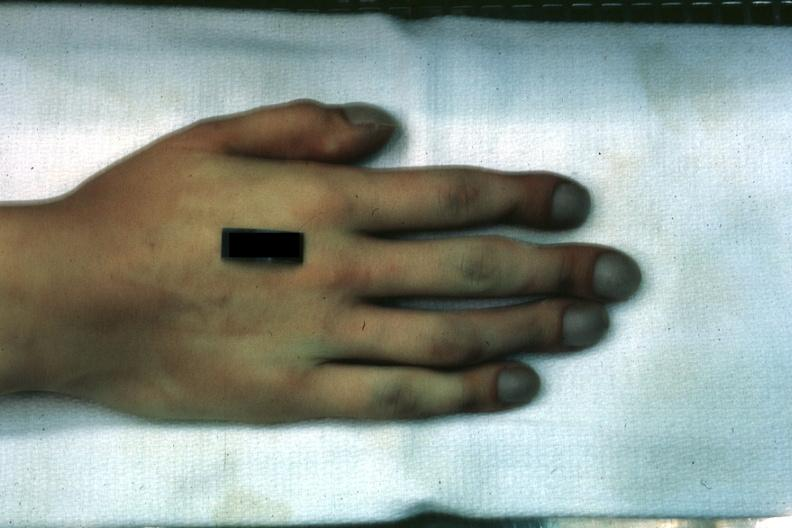what are present?
Answer the question using a single word or phrase. Extremities 